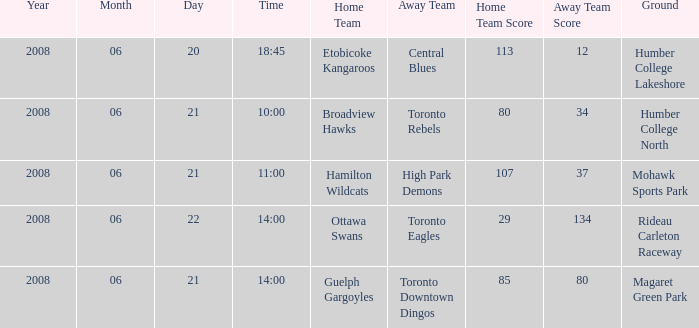What is the Time with a Score that is 80-34? 10:00. 